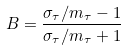Convert formula to latex. <formula><loc_0><loc_0><loc_500><loc_500>B = \frac { \sigma _ { \tau } / m _ { \tau } - 1 } { \sigma _ { \tau } / m _ { \tau } + 1 }</formula> 